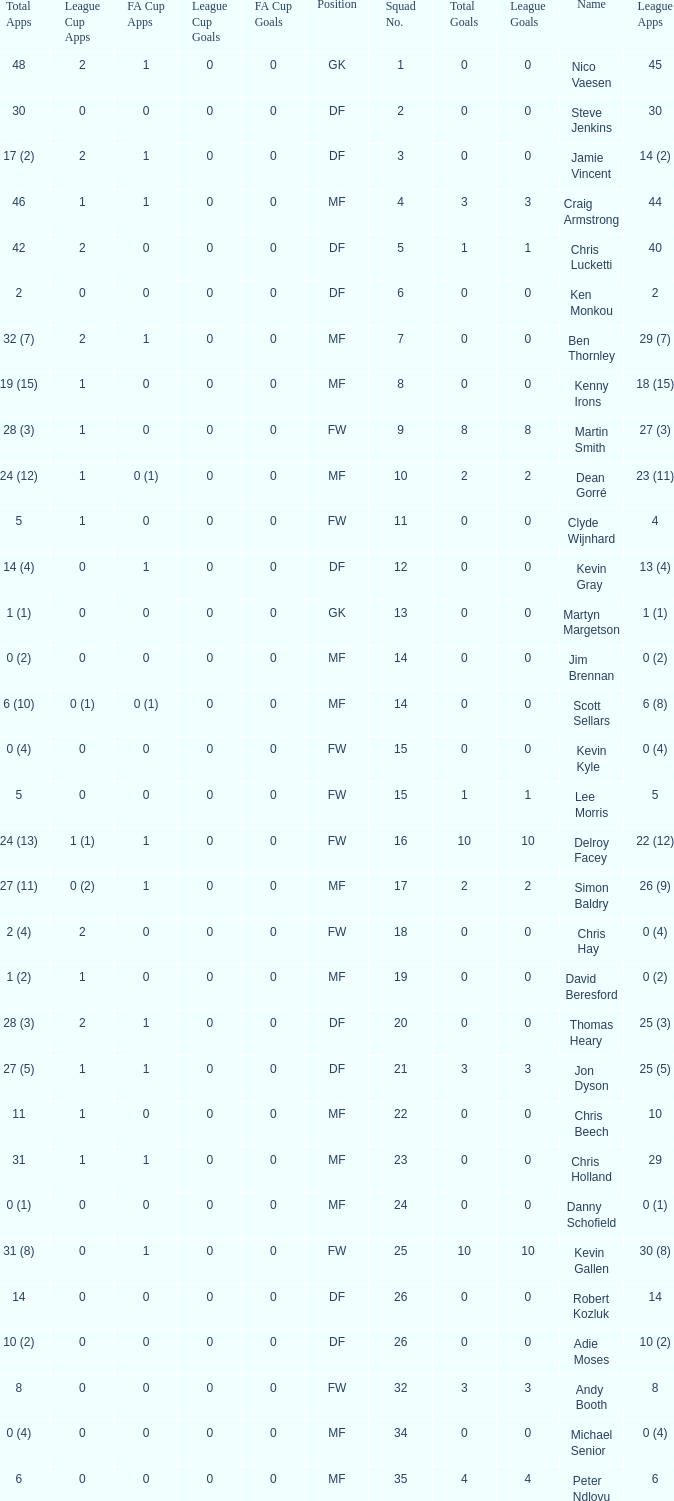Can you tell me the sum of FA Cup Goals that has the League Cup Goals larger than 0? None. 